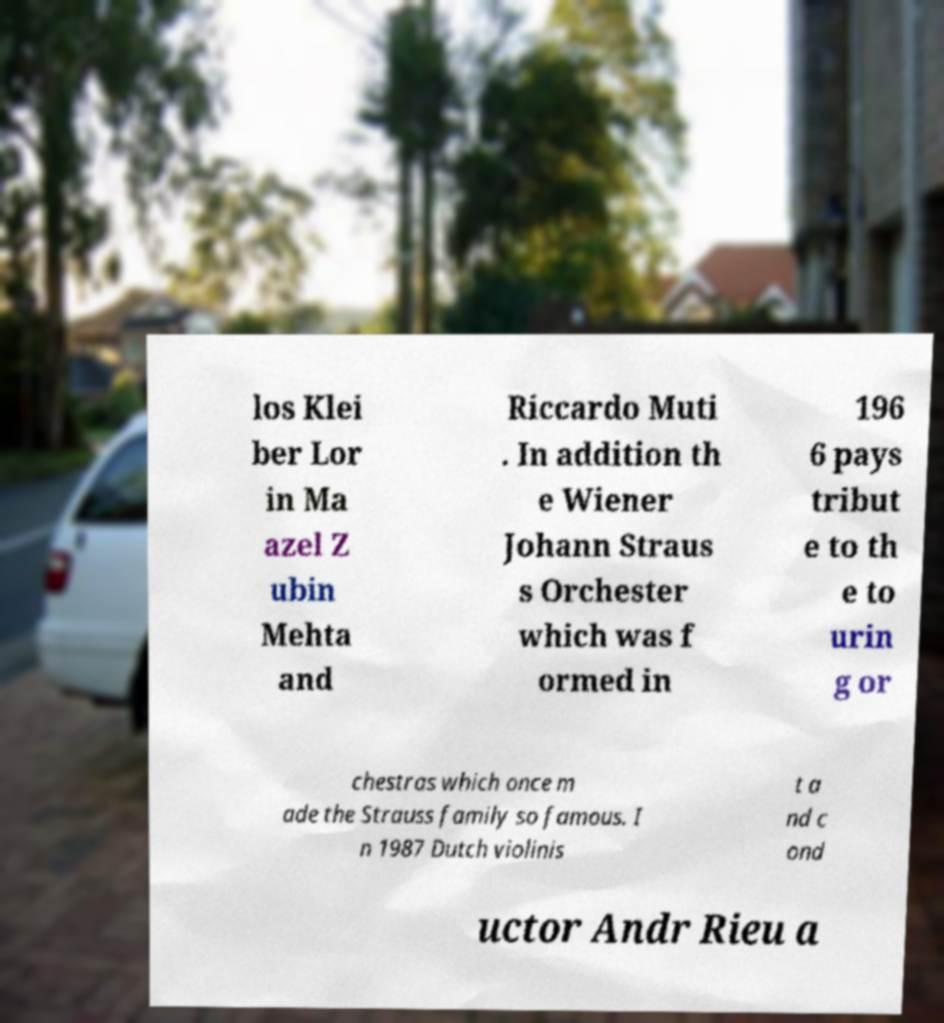For documentation purposes, I need the text within this image transcribed. Could you provide that? los Klei ber Lor in Ma azel Z ubin Mehta and Riccardo Muti . In addition th e Wiener Johann Straus s Orchester which was f ormed in 196 6 pays tribut e to th e to urin g or chestras which once m ade the Strauss family so famous. I n 1987 Dutch violinis t a nd c ond uctor Andr Rieu a 